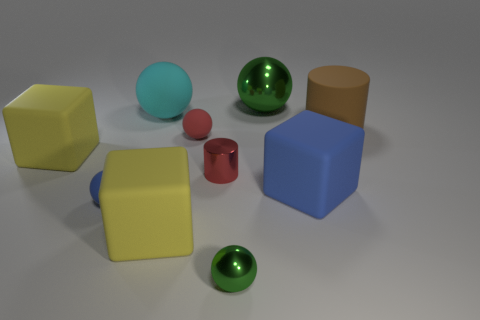There is another thing that is the same shape as the small red metal thing; what is its material?
Give a very brief answer. Rubber. What is the shape of the large rubber thing that is in front of the big brown rubber cylinder and behind the small red cylinder?
Offer a terse response. Cube. The large brown object that is made of the same material as the large blue thing is what shape?
Your answer should be compact. Cylinder. What is the cyan sphere on the right side of the small blue object made of?
Your answer should be compact. Rubber. Does the green ball behind the large brown matte cylinder have the same size as the green metal object in front of the large brown matte cylinder?
Give a very brief answer. No. What color is the tiny cylinder?
Keep it short and to the point. Red. Do the blue object to the right of the cyan thing and the brown rubber thing have the same shape?
Keep it short and to the point. No. What material is the red cylinder?
Provide a succinct answer. Metal. There is a blue object that is the same size as the cyan rubber thing; what is its shape?
Keep it short and to the point. Cube. Are there any large shiny things of the same color as the big matte cylinder?
Offer a very short reply. No. 